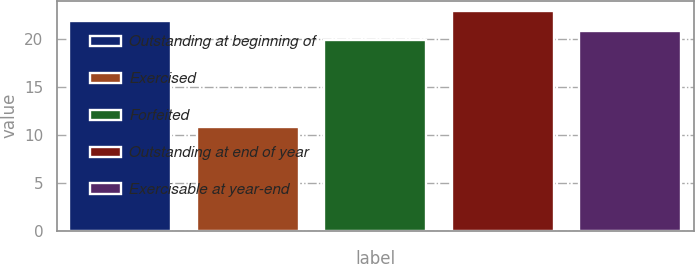Convert chart to OTSL. <chart><loc_0><loc_0><loc_500><loc_500><bar_chart><fcel>Outstanding at beginning of<fcel>Exercised<fcel>Forfeited<fcel>Outstanding at end of year<fcel>Exercisable at year-end<nl><fcel>21.82<fcel>10.75<fcel>19.83<fcel>22.82<fcel>20.82<nl></chart> 